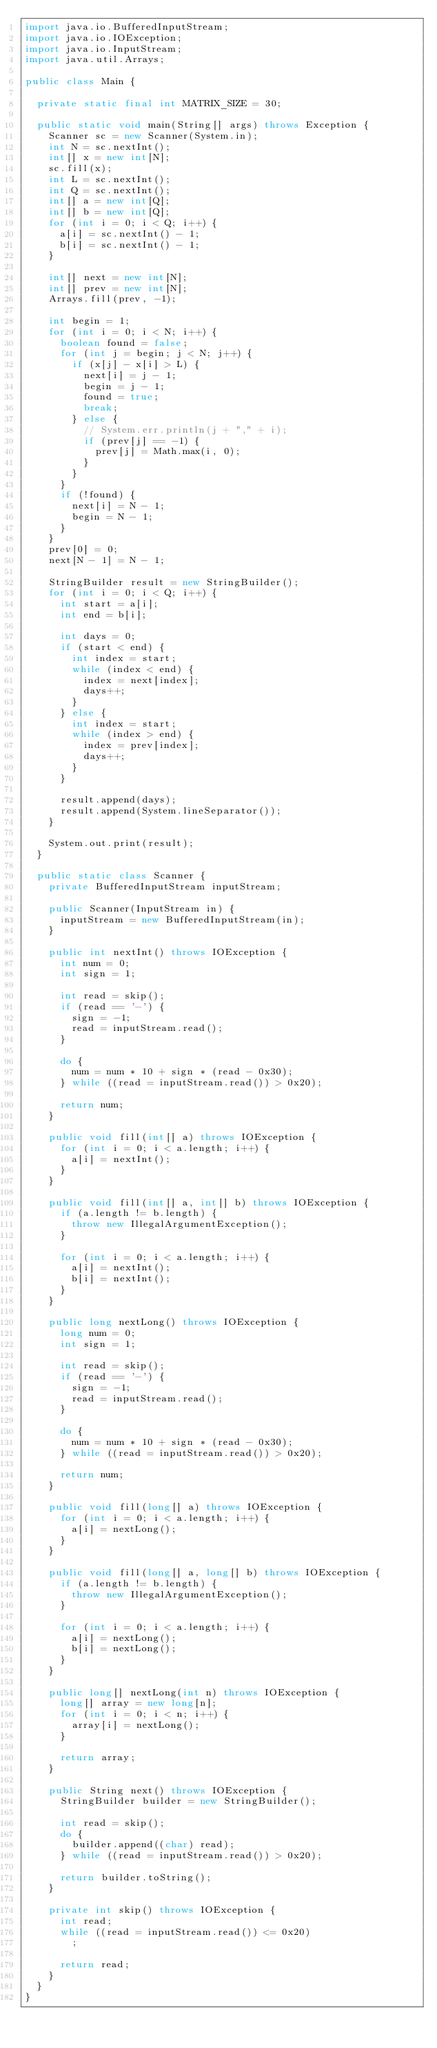<code> <loc_0><loc_0><loc_500><loc_500><_Java_>import java.io.BufferedInputStream;
import java.io.IOException;
import java.io.InputStream;
import java.util.Arrays;

public class Main {

	private static final int MATRIX_SIZE = 30;

	public static void main(String[] args) throws Exception {
		Scanner sc = new Scanner(System.in);
		int N = sc.nextInt();
		int[] x = new int[N];
		sc.fill(x);
		int L = sc.nextInt();
		int Q = sc.nextInt();
		int[] a = new int[Q];
		int[] b = new int[Q];
		for (int i = 0; i < Q; i++) {
			a[i] = sc.nextInt() - 1;
			b[i] = sc.nextInt() - 1;
		}

		int[] next = new int[N];
		int[] prev = new int[N];
		Arrays.fill(prev, -1);

		int begin = 1;
		for (int i = 0; i < N; i++) {
			boolean found = false;
			for (int j = begin; j < N; j++) {
				if (x[j] - x[i] > L) {
					next[i] = j - 1;
					begin = j - 1;
					found = true;
					break;
				} else {
					// System.err.println(j + "," + i);
					if (prev[j] == -1) {
						prev[j] = Math.max(i, 0);
					}
				}
			}
			if (!found) {
				next[i] = N - 1;
				begin = N - 1;
			}
		}
		prev[0] = 0;
		next[N - 1] = N - 1;

		StringBuilder result = new StringBuilder();
		for (int i = 0; i < Q; i++) {
			int start = a[i];
			int end = b[i];

			int days = 0;
			if (start < end) {
				int index = start;
				while (index < end) {
					index = next[index];
					days++;
				}
			} else {
				int index = start;
				while (index > end) {
					index = prev[index];
					days++;
				}
			}

			result.append(days);
			result.append(System.lineSeparator());
		}

		System.out.print(result);
	}

	public static class Scanner {
		private BufferedInputStream inputStream;

		public Scanner(InputStream in) {
			inputStream = new BufferedInputStream(in);
		}

		public int nextInt() throws IOException {
			int num = 0;
			int sign = 1;

			int read = skip();
			if (read == '-') {
				sign = -1;
				read = inputStream.read();
			}

			do {
				num = num * 10 + sign * (read - 0x30);
			} while ((read = inputStream.read()) > 0x20);

			return num;
		}

		public void fill(int[] a) throws IOException {
			for (int i = 0; i < a.length; i++) {
				a[i] = nextInt();
			}
		}

		public void fill(int[] a, int[] b) throws IOException {
			if (a.length != b.length) {
				throw new IllegalArgumentException();
			}

			for (int i = 0; i < a.length; i++) {
				a[i] = nextInt();
				b[i] = nextInt();
			}
		}

		public long nextLong() throws IOException {
			long num = 0;
			int sign = 1;

			int read = skip();
			if (read == '-') {
				sign = -1;
				read = inputStream.read();
			}

			do {
				num = num * 10 + sign * (read - 0x30);
			} while ((read = inputStream.read()) > 0x20);

			return num;
		}

		public void fill(long[] a) throws IOException {
			for (int i = 0; i < a.length; i++) {
				a[i] = nextLong();
			}
		}

		public void fill(long[] a, long[] b) throws IOException {
			if (a.length != b.length) {
				throw new IllegalArgumentException();
			}

			for (int i = 0; i < a.length; i++) {
				a[i] = nextLong();
				b[i] = nextLong();
			}
		}

		public long[] nextLong(int n) throws IOException {
			long[] array = new long[n];
			for (int i = 0; i < n; i++) {
				array[i] = nextLong();
			}

			return array;
		}

		public String next() throws IOException {
			StringBuilder builder = new StringBuilder();

			int read = skip();
			do {
				builder.append((char) read);
			} while ((read = inputStream.read()) > 0x20);

			return builder.toString();
		}

		private int skip() throws IOException {
			int read;
			while ((read = inputStream.read()) <= 0x20)
				;

			return read;
		}
	}
}
</code> 